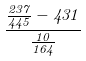<formula> <loc_0><loc_0><loc_500><loc_500>\frac { \frac { 2 3 7 } { 4 4 5 } - 4 3 1 } { \frac { 1 0 } { 1 6 4 } }</formula> 